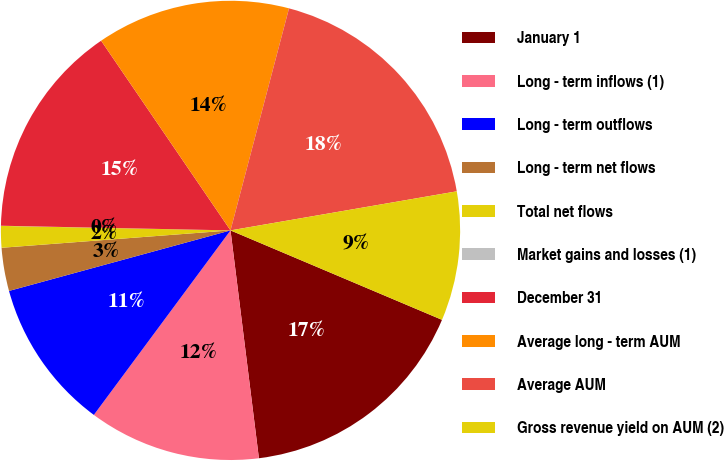<chart> <loc_0><loc_0><loc_500><loc_500><pie_chart><fcel>January 1<fcel>Long - term inflows (1)<fcel>Long - term outflows<fcel>Long - term net flows<fcel>Total net flows<fcel>Market gains and losses (1)<fcel>December 31<fcel>Average long - term AUM<fcel>Average AUM<fcel>Gross revenue yield on AUM (2)<nl><fcel>16.66%<fcel>12.12%<fcel>10.61%<fcel>3.04%<fcel>1.52%<fcel>0.01%<fcel>15.15%<fcel>13.63%<fcel>18.18%<fcel>9.09%<nl></chart> 